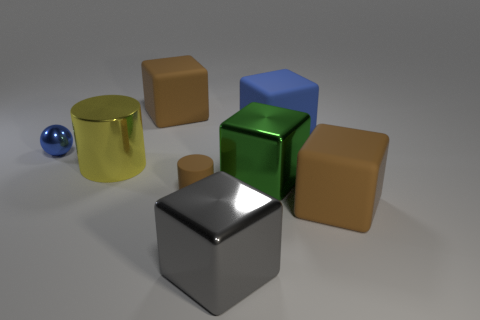Is there any other thing that is the same shape as the tiny blue shiny thing?
Give a very brief answer. No. What is the color of the matte thing that is both to the right of the brown cylinder and in front of the blue matte thing?
Provide a succinct answer. Brown. Is there any other thing that is the same color as the tiny matte cylinder?
Provide a succinct answer. Yes. What is the shape of the large thing that is in front of the brown matte cube that is to the right of the tiny object that is to the right of the tiny blue shiny ball?
Your answer should be compact. Cube. The other large metal thing that is the same shape as the green metal object is what color?
Offer a terse response. Gray. The metal cube that is behind the small thing in front of the tiny shiny thing is what color?
Make the answer very short. Green. The blue object that is the same shape as the green metal thing is what size?
Provide a short and direct response. Large. What number of gray blocks are the same material as the green object?
Make the answer very short. 1. How many large matte blocks are to the right of the brown matte thing behind the small rubber object?
Your answer should be very brief. 2. Are there any small brown matte cylinders left of the big metal cylinder?
Give a very brief answer. No. 